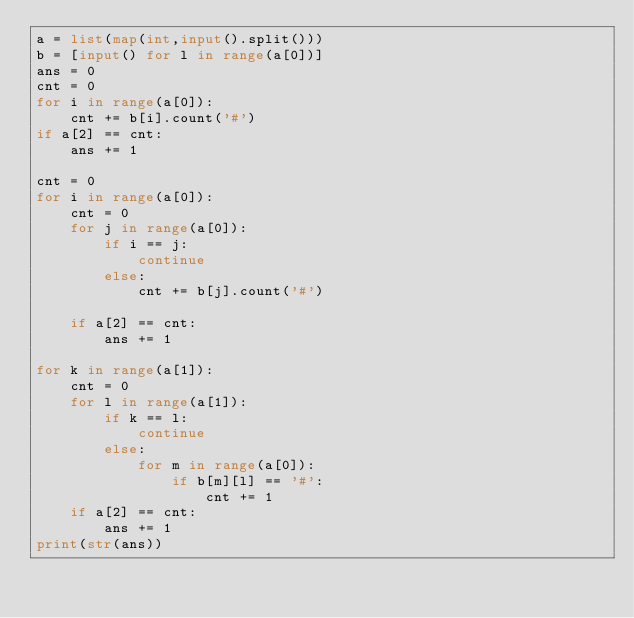<code> <loc_0><loc_0><loc_500><loc_500><_Python_>a = list(map(int,input().split()))
b = [input() for l in range(a[0])]
ans = 0
cnt = 0
for i in range(a[0]):
    cnt += b[i].count('#')
if a[2] == cnt:
    ans += 1

cnt = 0
for i in range(a[0]):
    cnt = 0
    for j in range(a[0]):
        if i == j:
            continue
        else:
            cnt += b[j].count('#')
    
    if a[2] == cnt:
        ans += 1

for k in range(a[1]):
    cnt = 0
    for l in range(a[1]):
        if k == l:
            continue
        else:
            for m in range(a[0]):
                if b[m][l] == '#':
                    cnt += 1 
    if a[2] == cnt:
        ans += 1        
print(str(ans))</code> 